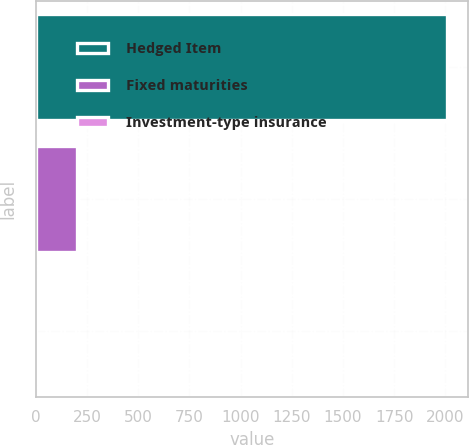Convert chart. <chart><loc_0><loc_0><loc_500><loc_500><bar_chart><fcel>Hedged Item<fcel>Fixed maturities<fcel>Investment-type insurance<nl><fcel>2008<fcel>203.23<fcel>2.7<nl></chart> 